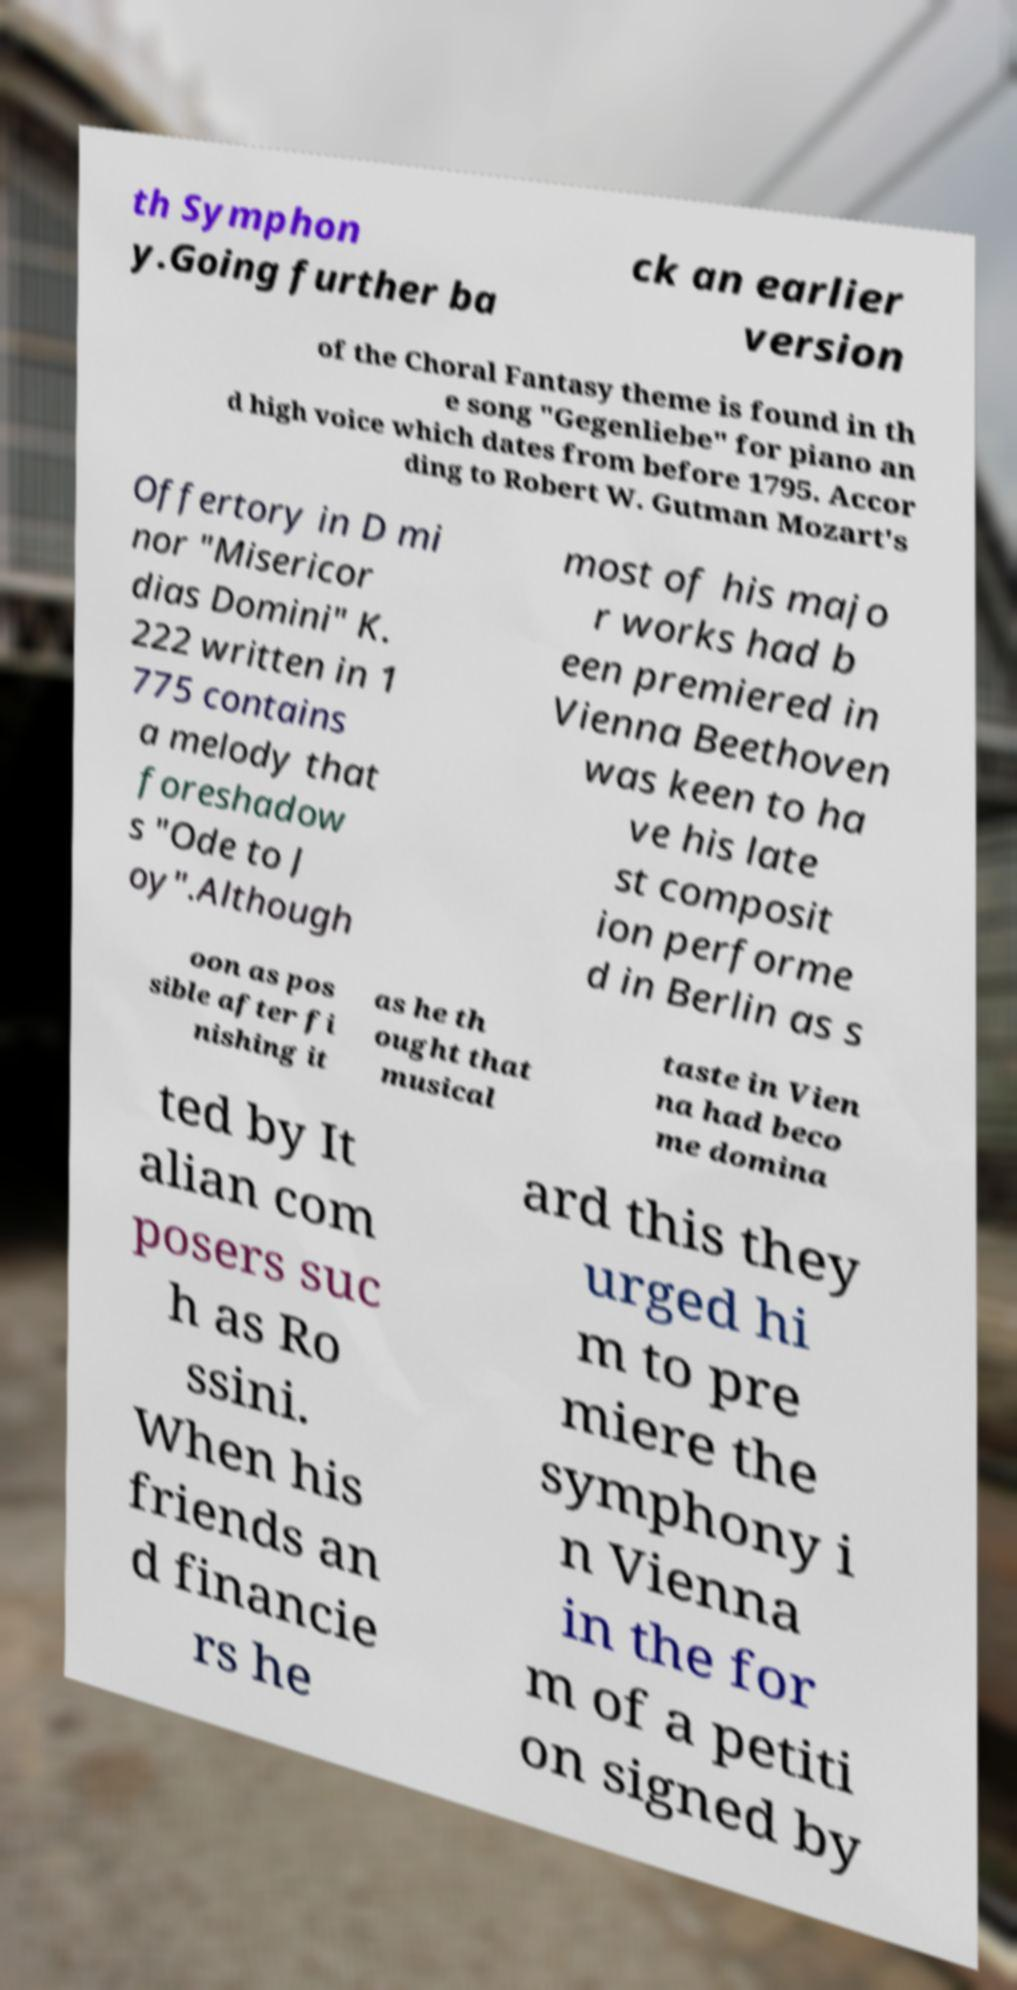I need the written content from this picture converted into text. Can you do that? th Symphon y.Going further ba ck an earlier version of the Choral Fantasy theme is found in th e song "Gegenliebe" for piano an d high voice which dates from before 1795. Accor ding to Robert W. Gutman Mozart's Offertory in D mi nor "Misericor dias Domini" K. 222 written in 1 775 contains a melody that foreshadow s "Ode to J oy".Although most of his majo r works had b een premiered in Vienna Beethoven was keen to ha ve his late st composit ion performe d in Berlin as s oon as pos sible after fi nishing it as he th ought that musical taste in Vien na had beco me domina ted by It alian com posers suc h as Ro ssini. When his friends an d financie rs he ard this they urged hi m to pre miere the symphony i n Vienna in the for m of a petiti on signed by 